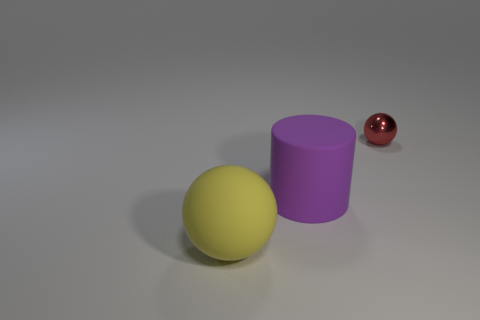Add 1 small yellow matte cylinders. How many objects exist? 4 Subtract all red balls. How many balls are left? 1 Subtract 0 yellow cubes. How many objects are left? 3 Subtract all spheres. How many objects are left? 1 Subtract all brown spheres. Subtract all cyan cylinders. How many spheres are left? 2 Subtract all gray balls. How many gray cylinders are left? 0 Subtract all green rubber cylinders. Subtract all small red metallic spheres. How many objects are left? 2 Add 3 balls. How many balls are left? 5 Add 1 big rubber objects. How many big rubber objects exist? 3 